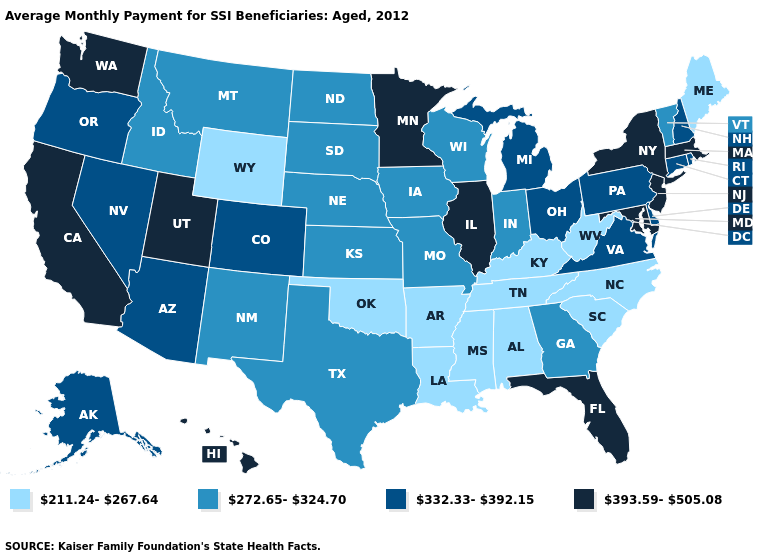What is the value of Utah?
Give a very brief answer. 393.59-505.08. Name the states that have a value in the range 272.65-324.70?
Write a very short answer. Georgia, Idaho, Indiana, Iowa, Kansas, Missouri, Montana, Nebraska, New Mexico, North Dakota, South Dakota, Texas, Vermont, Wisconsin. Which states hav the highest value in the MidWest?
Write a very short answer. Illinois, Minnesota. What is the value of Nevada?
Write a very short answer. 332.33-392.15. Does Alabama have a lower value than Missouri?
Be succinct. Yes. Does Pennsylvania have a higher value than Delaware?
Write a very short answer. No. Does the first symbol in the legend represent the smallest category?
Be succinct. Yes. Name the states that have a value in the range 272.65-324.70?
Give a very brief answer. Georgia, Idaho, Indiana, Iowa, Kansas, Missouri, Montana, Nebraska, New Mexico, North Dakota, South Dakota, Texas, Vermont, Wisconsin. Among the states that border Arkansas , which have the highest value?
Give a very brief answer. Missouri, Texas. What is the lowest value in the USA?
Answer briefly. 211.24-267.64. Does the first symbol in the legend represent the smallest category?
Short answer required. Yes. Among the states that border Kentucky , does Tennessee have the highest value?
Keep it brief. No. Name the states that have a value in the range 332.33-392.15?
Keep it brief. Alaska, Arizona, Colorado, Connecticut, Delaware, Michigan, Nevada, New Hampshire, Ohio, Oregon, Pennsylvania, Rhode Island, Virginia. Does Tennessee have a lower value than New Jersey?
Write a very short answer. Yes. Among the states that border Illinois , which have the lowest value?
Concise answer only. Kentucky. 